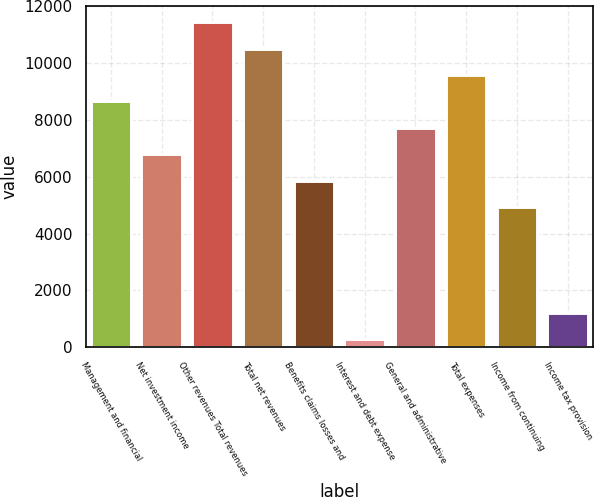<chart> <loc_0><loc_0><loc_500><loc_500><bar_chart><fcel>Management and financial<fcel>Net investment income<fcel>Other revenues Total revenues<fcel>Total net revenues<fcel>Benefits claims losses and<fcel>Interest and debt expense<fcel>General and administrative<fcel>Total expenses<fcel>Income from continuing<fcel>Income tax provision<nl><fcel>8652.8<fcel>6794.4<fcel>11440.4<fcel>10511.2<fcel>5865.2<fcel>290<fcel>7723.6<fcel>9582<fcel>4936<fcel>1219.2<nl></chart> 